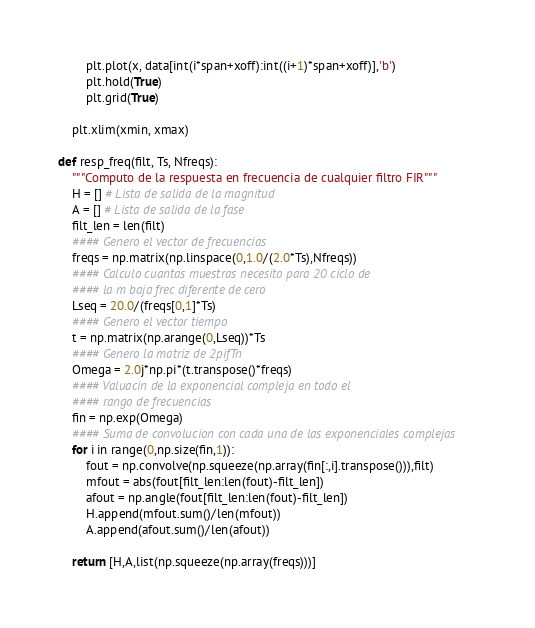<code> <loc_0><loc_0><loc_500><loc_500><_Python_>        plt.plot(x, data[int(i*span+xoff):int((i+1)*span+xoff)],'b')
        plt.hold(True)
        plt.grid(True)

    plt.xlim(xmin, xmax)

def resp_freq(filt, Ts, Nfreqs):
    """Computo de la respuesta en frecuencia de cualquier filtro FIR"""
    H = [] # Lista de salida de la magnitud
    A = [] # Lista de salida de la fase
    filt_len = len(filt)
    #### Genero el vector de frecuencias
    freqs = np.matrix(np.linspace(0,1.0/(2.0*Ts),Nfreqs))
    #### Calculo cuantas muestras necesito para 20 ciclo de
    #### la m baja frec diferente de cero
    Lseq = 20.0/(freqs[0,1]*Ts)
    #### Genero el vector tiempo
    t = np.matrix(np.arange(0,Lseq))*Ts
    #### Genero la matriz de 2pifTn
    Omega = 2.0j*np.pi*(t.transpose()*freqs)
    #### Valuacin de la exponencial compleja en todo el
    #### rango de frecuencias
    fin = np.exp(Omega)
    #### Suma de convolucion con cada una de las exponenciales complejas
    for i in range(0,np.size(fin,1)):
        fout = np.convolve(np.squeeze(np.array(fin[:,i].transpose())),filt)
        mfout = abs(fout[filt_len:len(fout)-filt_len])
        afout = np.angle(fout[filt_len:len(fout)-filt_len])
        H.append(mfout.sum()/len(mfout))
        A.append(afout.sum()/len(afout))

    return [H,A,list(np.squeeze(np.array(freqs)))]
</code> 